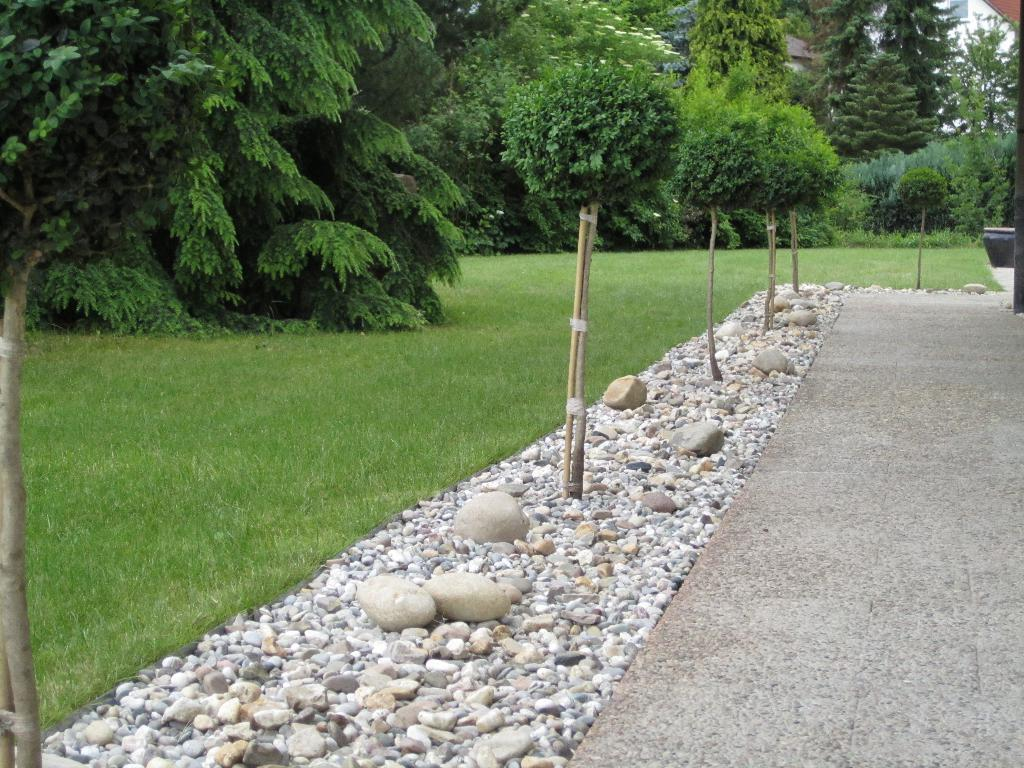What type of natural elements can be seen in the image? There are stones and grass in the image. Where are the stones and grass located? The grass and stones are on the land in the image. What other objects can be seen in the image? There are wooden sticks visible in the image. What can be seen in the background of the image? There are trees in the background of the image. What type of lettuce is growing in the image? There is no lettuce present in the image; it features stones, grass, wooden sticks, and trees. What is the weather like in the image? The provided facts do not mention the weather, so it cannot be determined from the image. 